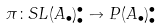Convert formula to latex. <formula><loc_0><loc_0><loc_500><loc_500>\pi \colon S L ( A _ { \bullet } ) _ { \bullet } ^ { \bullet } \to P ( A _ { \bullet } ) _ { \bullet } ^ { \bullet }</formula> 